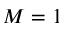<formula> <loc_0><loc_0><loc_500><loc_500>M = 1</formula> 